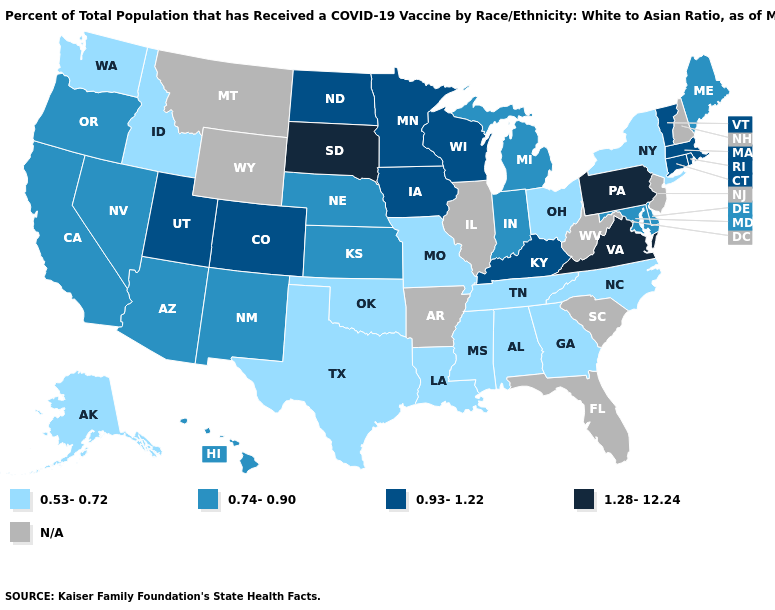What is the value of Colorado?
Quick response, please. 0.93-1.22. Name the states that have a value in the range 0.53-0.72?
Write a very short answer. Alabama, Alaska, Georgia, Idaho, Louisiana, Mississippi, Missouri, New York, North Carolina, Ohio, Oklahoma, Tennessee, Texas, Washington. What is the value of Massachusetts?
Answer briefly. 0.93-1.22. Is the legend a continuous bar?
Short answer required. No. Which states have the lowest value in the USA?
Answer briefly. Alabama, Alaska, Georgia, Idaho, Louisiana, Mississippi, Missouri, New York, North Carolina, Ohio, Oklahoma, Tennessee, Texas, Washington. Does Pennsylvania have the highest value in the USA?
Keep it brief. Yes. Name the states that have a value in the range 0.53-0.72?
Keep it brief. Alabama, Alaska, Georgia, Idaho, Louisiana, Mississippi, Missouri, New York, North Carolina, Ohio, Oklahoma, Tennessee, Texas, Washington. What is the highest value in the South ?
Give a very brief answer. 1.28-12.24. Does Rhode Island have the lowest value in the USA?
Quick response, please. No. Name the states that have a value in the range 0.93-1.22?
Answer briefly. Colorado, Connecticut, Iowa, Kentucky, Massachusetts, Minnesota, North Dakota, Rhode Island, Utah, Vermont, Wisconsin. Which states have the highest value in the USA?
Answer briefly. Pennsylvania, South Dakota, Virginia. Which states have the lowest value in the MidWest?
Answer briefly. Missouri, Ohio. What is the highest value in the MidWest ?
Short answer required. 1.28-12.24. What is the highest value in states that border Massachusetts?
Quick response, please. 0.93-1.22. 